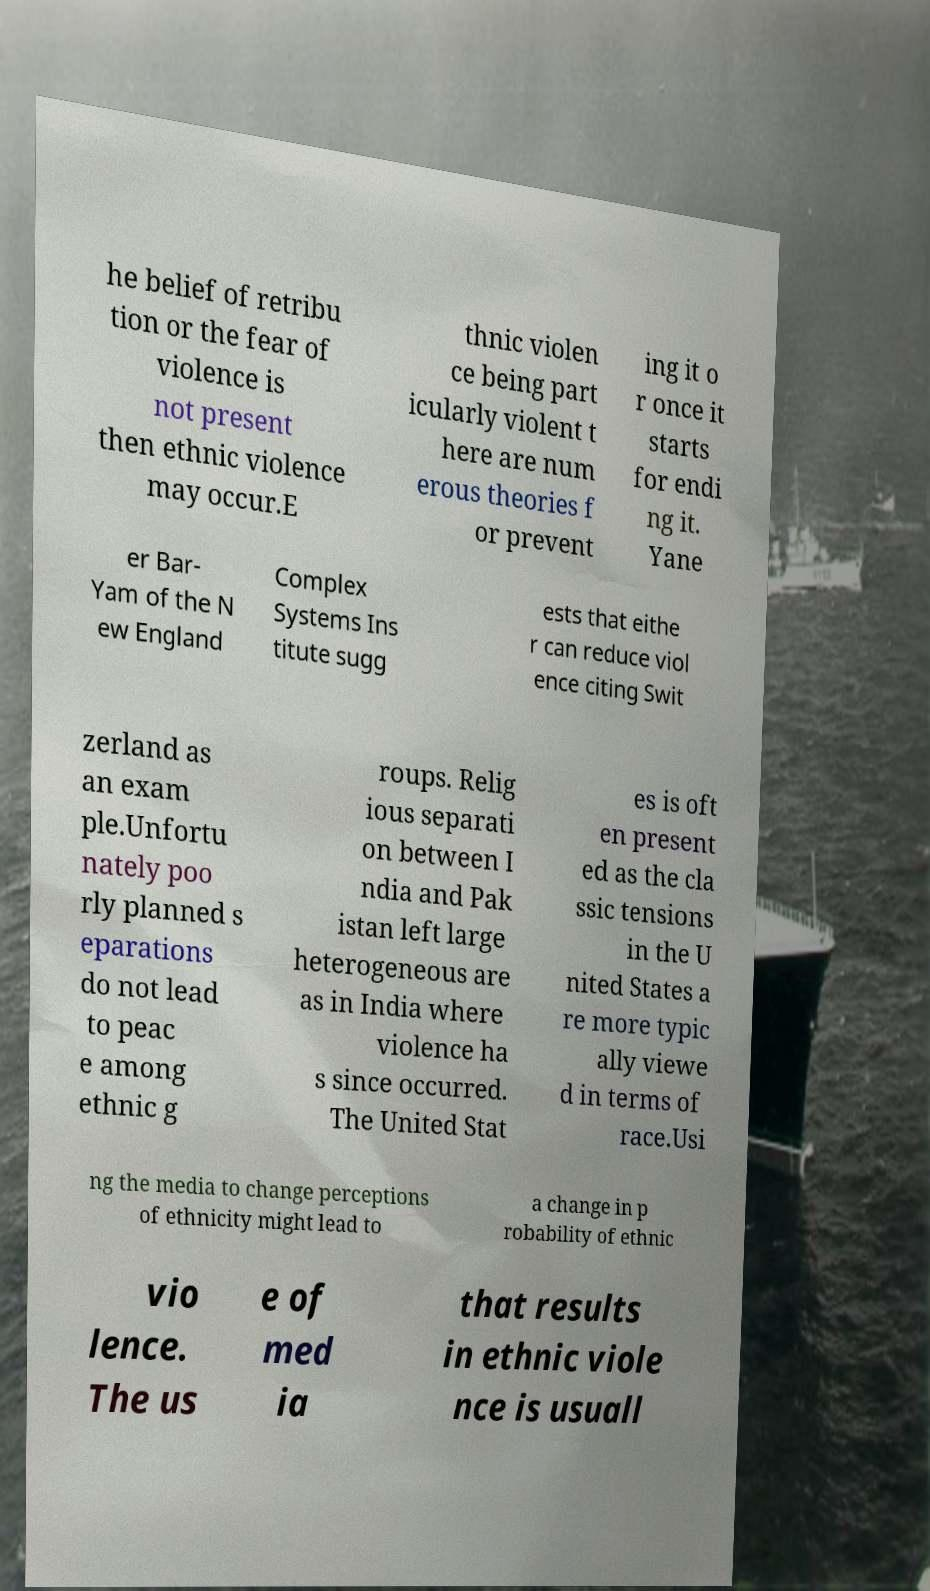Could you assist in decoding the text presented in this image and type it out clearly? he belief of retribu tion or the fear of violence is not present then ethnic violence may occur.E thnic violen ce being part icularly violent t here are num erous theories f or prevent ing it o r once it starts for endi ng it. Yane er Bar- Yam of the N ew England Complex Systems Ins titute sugg ests that eithe r can reduce viol ence citing Swit zerland as an exam ple.Unfortu nately poo rly planned s eparations do not lead to peac e among ethnic g roups. Relig ious separati on between I ndia and Pak istan left large heterogeneous are as in India where violence ha s since occurred. The United Stat es is oft en present ed as the cla ssic tensions in the U nited States a re more typic ally viewe d in terms of race.Usi ng the media to change perceptions of ethnicity might lead to a change in p robability of ethnic vio lence. The us e of med ia that results in ethnic viole nce is usuall 